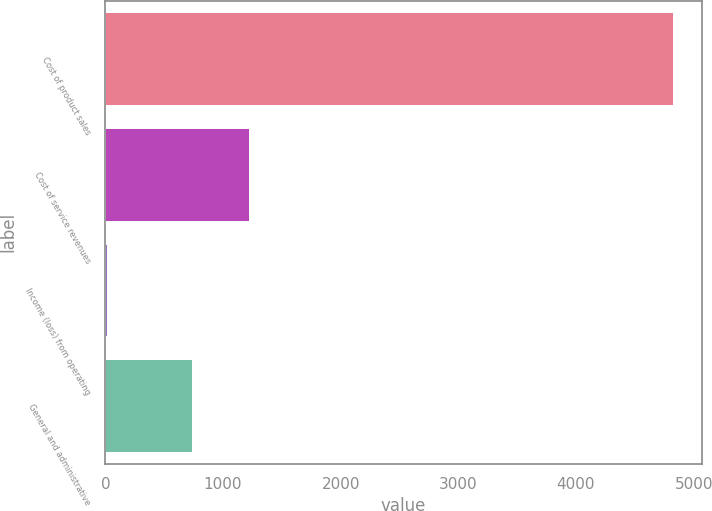<chart> <loc_0><loc_0><loc_500><loc_500><bar_chart><fcel>Cost of product sales<fcel>Cost of service revenues<fcel>Income (loss) from operating<fcel>General and administrative<nl><fcel>4827<fcel>1219.9<fcel>18<fcel>739<nl></chart> 